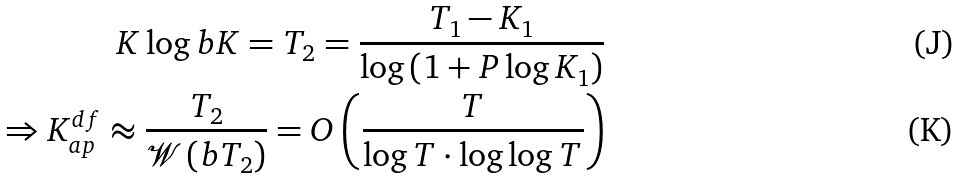<formula> <loc_0><loc_0><loc_500><loc_500>K \log b K = T _ { 2 } = \frac { T _ { 1 } - K _ { 1 } } { \log \left ( 1 + P \log K _ { 1 } \right ) } \\ \Rightarrow K ^ { d f } _ { a p } \approx \frac { T _ { 2 } } { \mathcal { W } \left ( b T _ { 2 } \right ) } = O \left ( \frac { T } { \log T \cdot \log \log T } \right )</formula> 